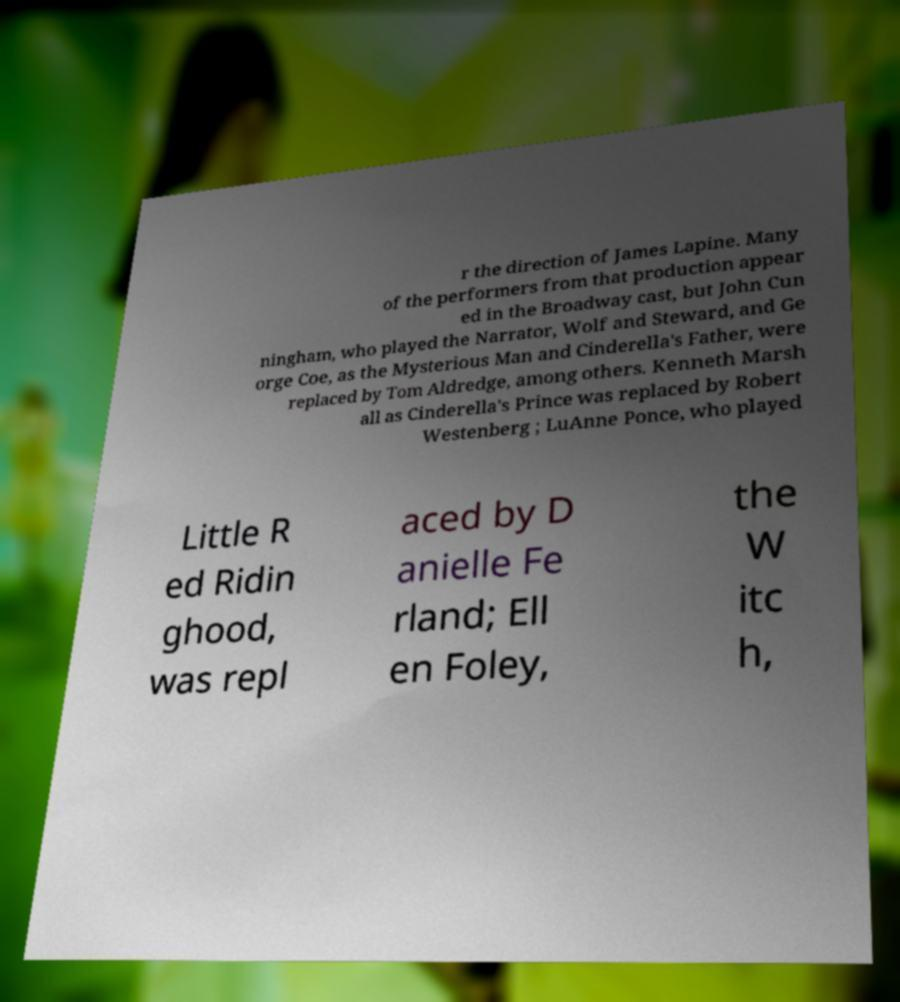There's text embedded in this image that I need extracted. Can you transcribe it verbatim? r the direction of James Lapine. Many of the performers from that production appear ed in the Broadway cast, but John Cun ningham, who played the Narrator, Wolf and Steward, and Ge orge Coe, as the Mysterious Man and Cinderella's Father, were replaced by Tom Aldredge, among others. Kenneth Marsh all as Cinderella's Prince was replaced by Robert Westenberg ; LuAnne Ponce, who played Little R ed Ridin ghood, was repl aced by D anielle Fe rland; Ell en Foley, the W itc h, 